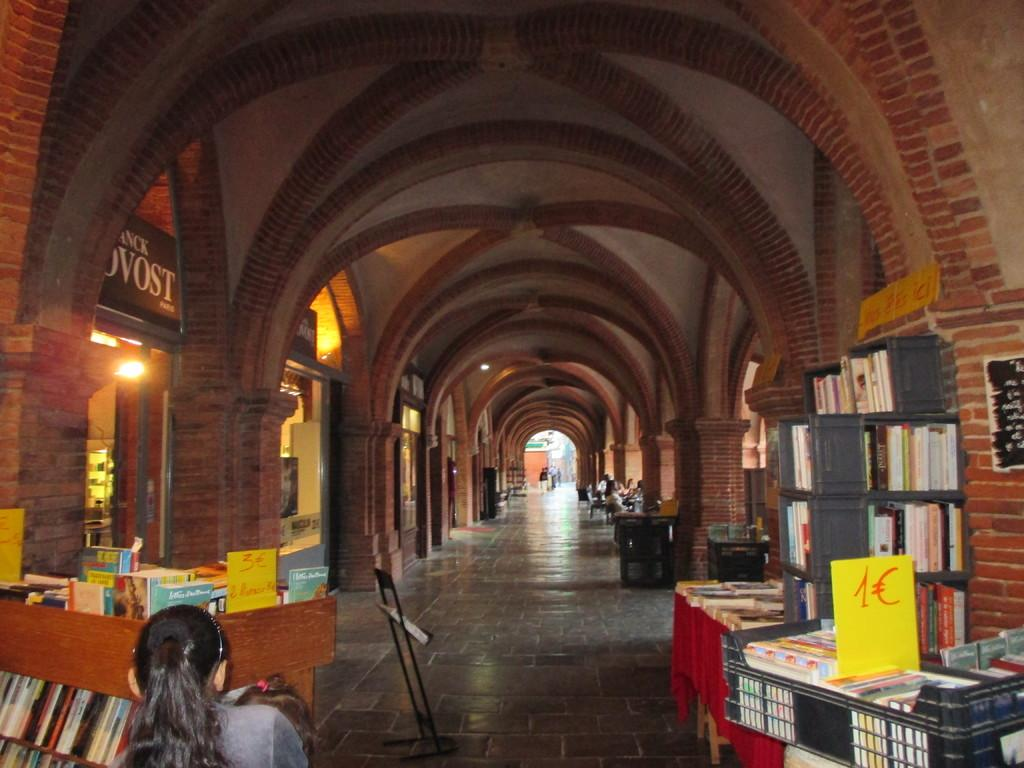<image>
Render a clear and concise summary of the photo. A black crate full of books says they cost 1 Euro each. 